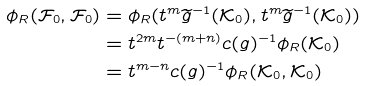<formula> <loc_0><loc_0><loc_500><loc_500>\phi _ { R } ( \mathcal { F } _ { 0 } , \mathcal { F } _ { 0 } ) & = \phi _ { R } ( t ^ { m } \widetilde { g } ^ { - 1 } ( \mathcal { K } _ { 0 } ) , t ^ { m } \widetilde { g } ^ { - 1 } ( \mathcal { K } _ { 0 } ) ) \\ & = t ^ { 2 m } t ^ { - ( m + n ) } c ( g ) ^ { - 1 } \phi _ { R } ( \mathcal { K } _ { 0 } ) \\ & = t ^ { m - n } c ( g ) ^ { - 1 } \phi _ { R } ( \mathcal { K } _ { 0 } , \mathcal { K } _ { 0 } )</formula> 